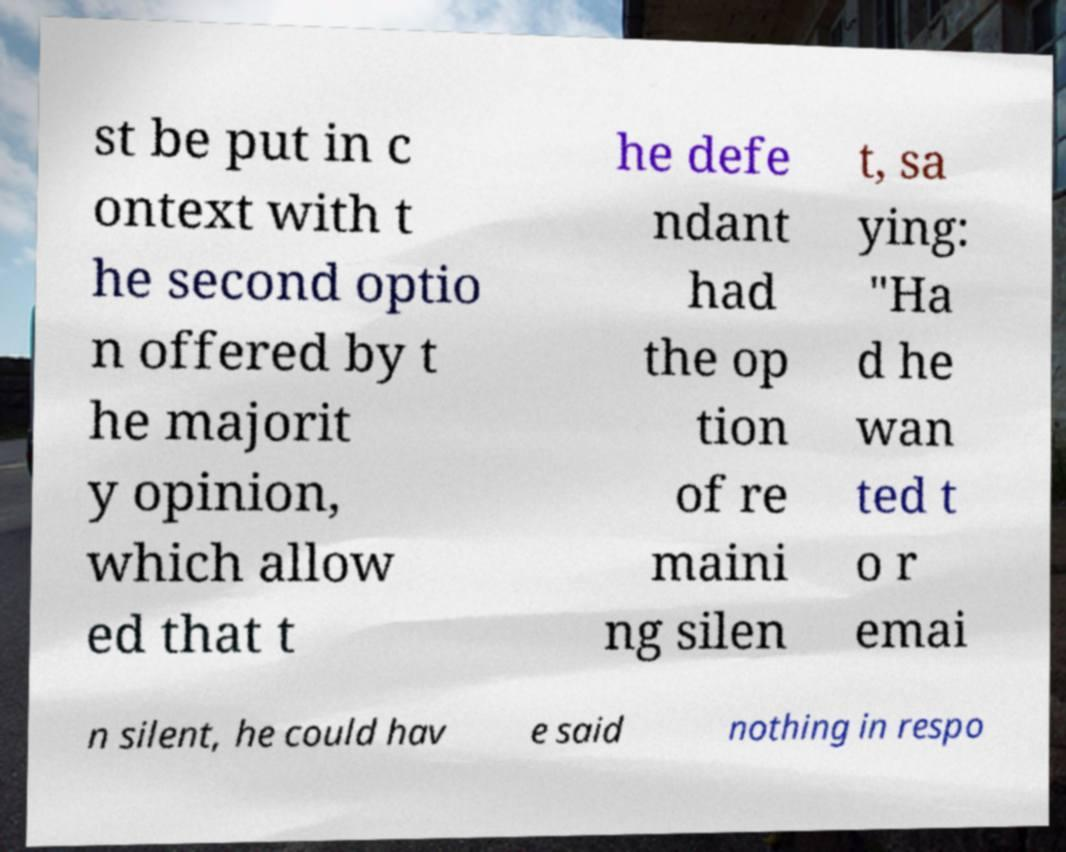Could you assist in decoding the text presented in this image and type it out clearly? st be put in c ontext with t he second optio n offered by t he majorit y opinion, which allow ed that t he defe ndant had the op tion of re maini ng silen t, sa ying: "Ha d he wan ted t o r emai n silent, he could hav e said nothing in respo 